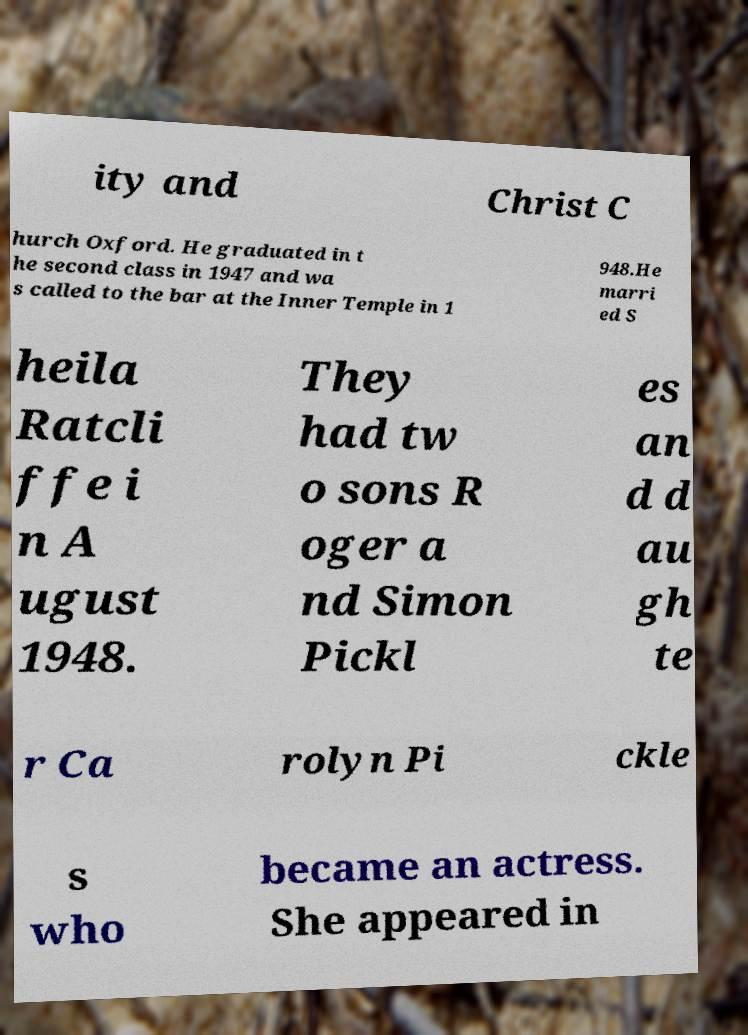Can you accurately transcribe the text from the provided image for me? ity and Christ C hurch Oxford. He graduated in t he second class in 1947 and wa s called to the bar at the Inner Temple in 1 948.He marri ed S heila Ratcli ffe i n A ugust 1948. They had tw o sons R oger a nd Simon Pickl es an d d au gh te r Ca rolyn Pi ckle s who became an actress. She appeared in 